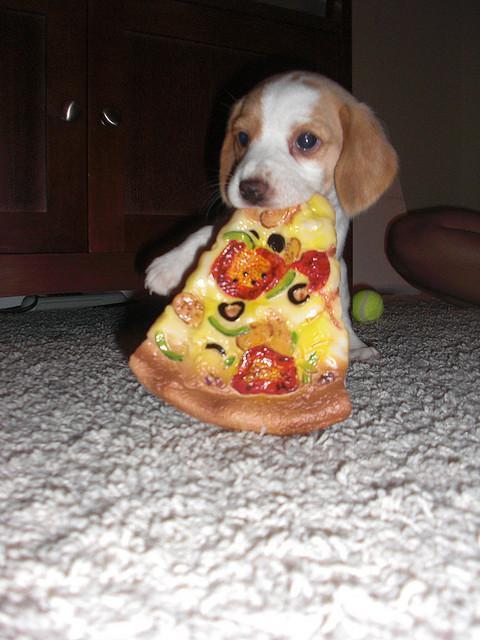How many stacks of bowls are there?
Give a very brief answer. 0. 